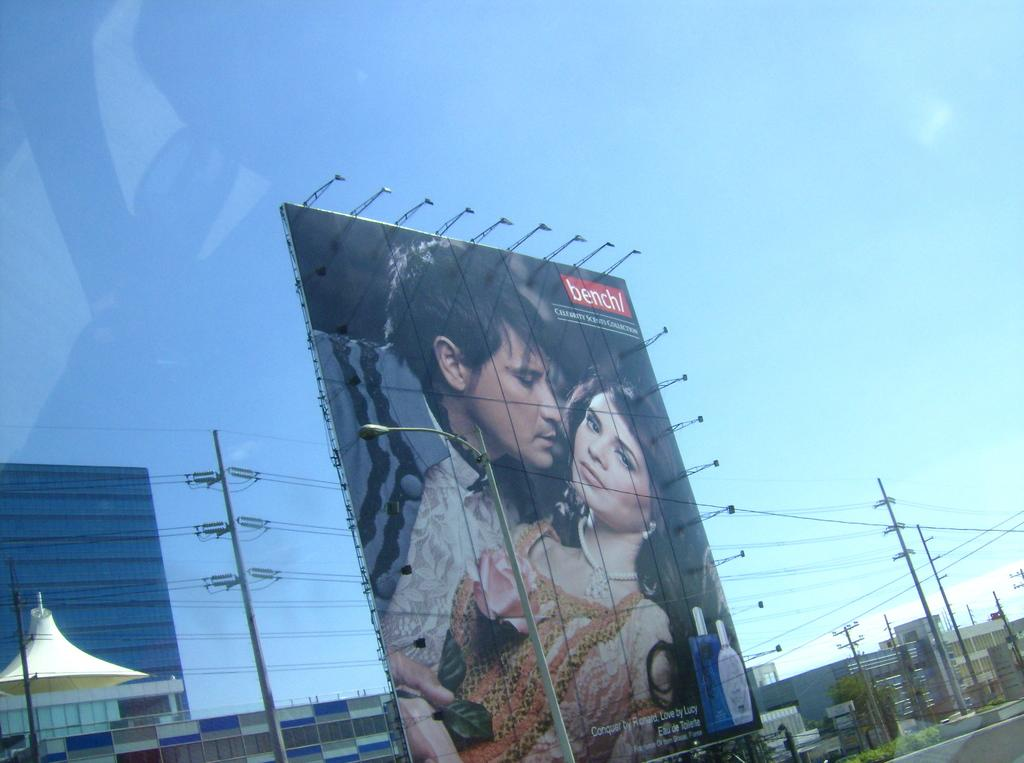What is the main object in the image? There is an advertisement hoarding in the image. Are there any people in the image? Yes, there is a man and a woman in the image. What type of structures can be seen in the image? There are buildings in the image. What else can be seen in the image besides the hoarding and people? There are poles in the image. How would you describe the sky in the image? The sky is blue and cloudy in the image. What type of bell can be heard ringing in the image? There is no bell present in the image, and therefore no sound can be heard. How many stitches are visible on the man's shirt in the image? There is no information about the man's shirt or any stitches in the image. 